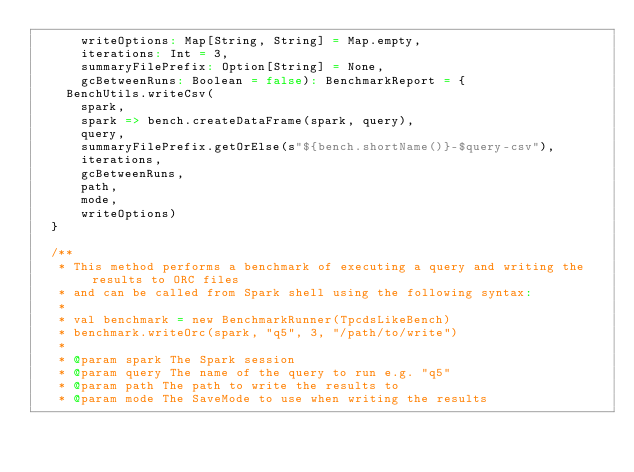<code> <loc_0><loc_0><loc_500><loc_500><_Scala_>      writeOptions: Map[String, String] = Map.empty,
      iterations: Int = 3,
      summaryFilePrefix: Option[String] = None,
      gcBetweenRuns: Boolean = false): BenchmarkReport = {
    BenchUtils.writeCsv(
      spark,
      spark => bench.createDataFrame(spark, query),
      query,
      summaryFilePrefix.getOrElse(s"${bench.shortName()}-$query-csv"),
      iterations,
      gcBetweenRuns,
      path,
      mode,
      writeOptions)
  }

  /**
   * This method performs a benchmark of executing a query and writing the results to ORC files
   * and can be called from Spark shell using the following syntax:
   *
   * val benchmark = new BenchmarkRunner(TpcdsLikeBench)
   * benchmark.writeOrc(spark, "q5", 3, "/path/to/write")
   *
   * @param spark The Spark session
   * @param query The name of the query to run e.g. "q5"
   * @param path The path to write the results to
   * @param mode The SaveMode to use when writing the results</code> 